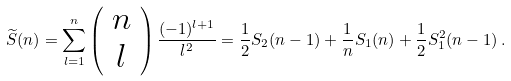Convert formula to latex. <formula><loc_0><loc_0><loc_500><loc_500>\widetilde { S } ( n ) = \sum _ { l = 1 } ^ { n } \left ( \begin{array} { c } n \\ l \end{array} \right ) \frac { ( - 1 ) ^ { l + 1 } } { l ^ { 2 } } = \frac { 1 } { 2 } S _ { 2 } ( n - 1 ) + \frac { 1 } { n } S _ { 1 } ( n ) + \frac { 1 } { 2 } S _ { 1 } ^ { 2 } ( n - 1 ) \, .</formula> 